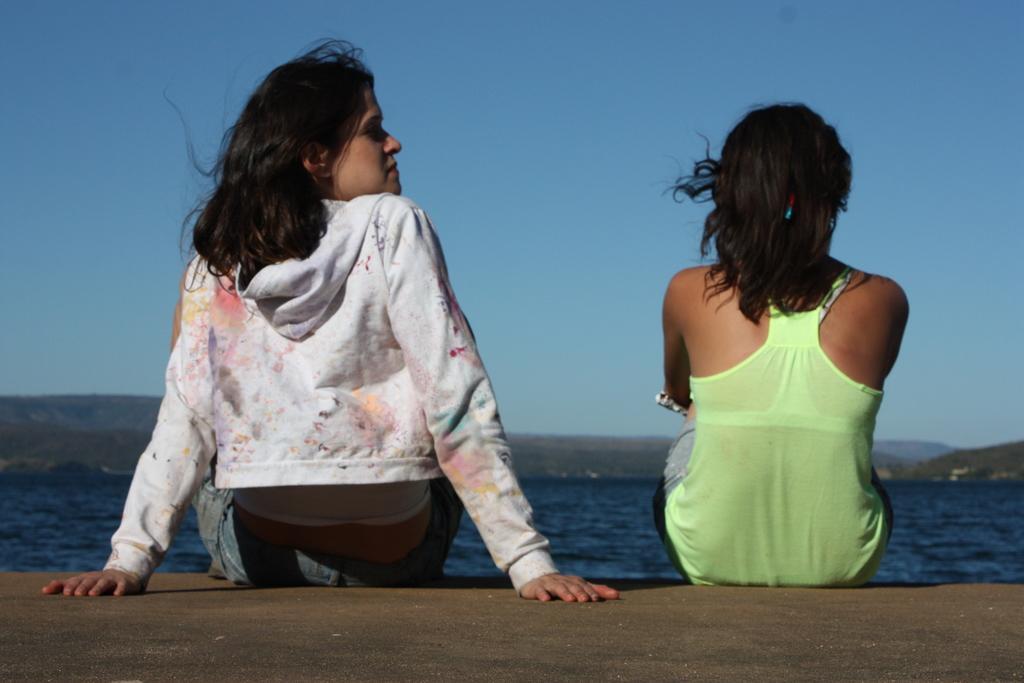How would you summarize this image in a sentence or two? In the center of the image we can see two persons are sitting on the platform. And we can see they are in different costumes. In the background, we can see the sky, hills and water. 